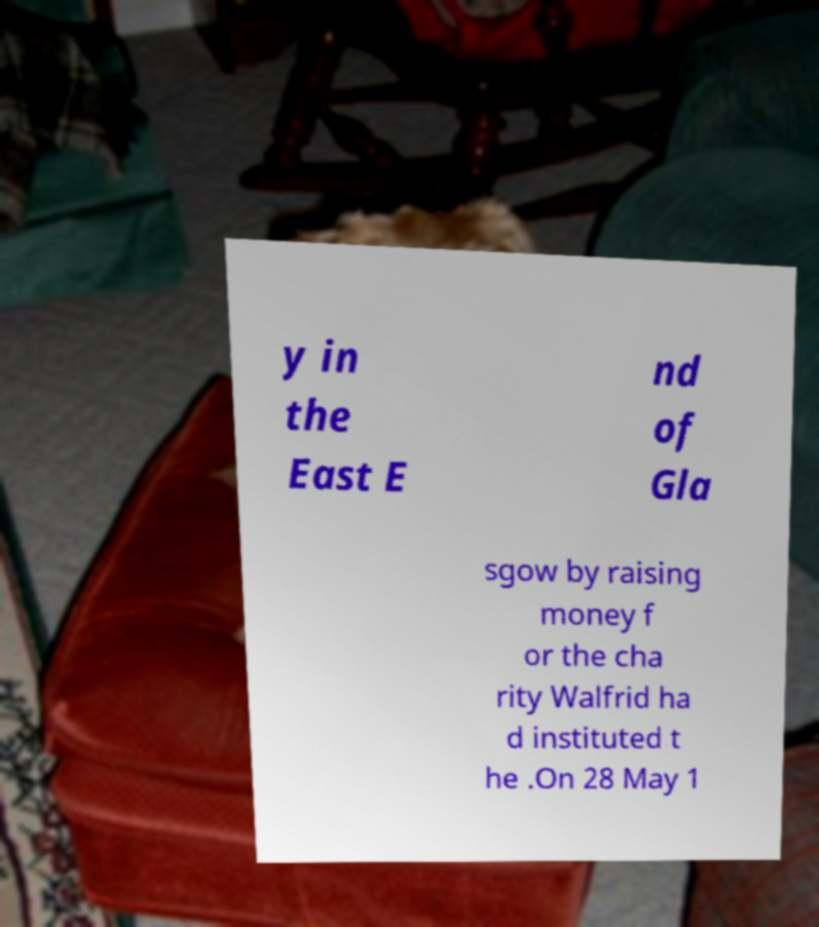Please read and relay the text visible in this image. What does it say? y in the East E nd of Gla sgow by raising money f or the cha rity Walfrid ha d instituted t he .On 28 May 1 